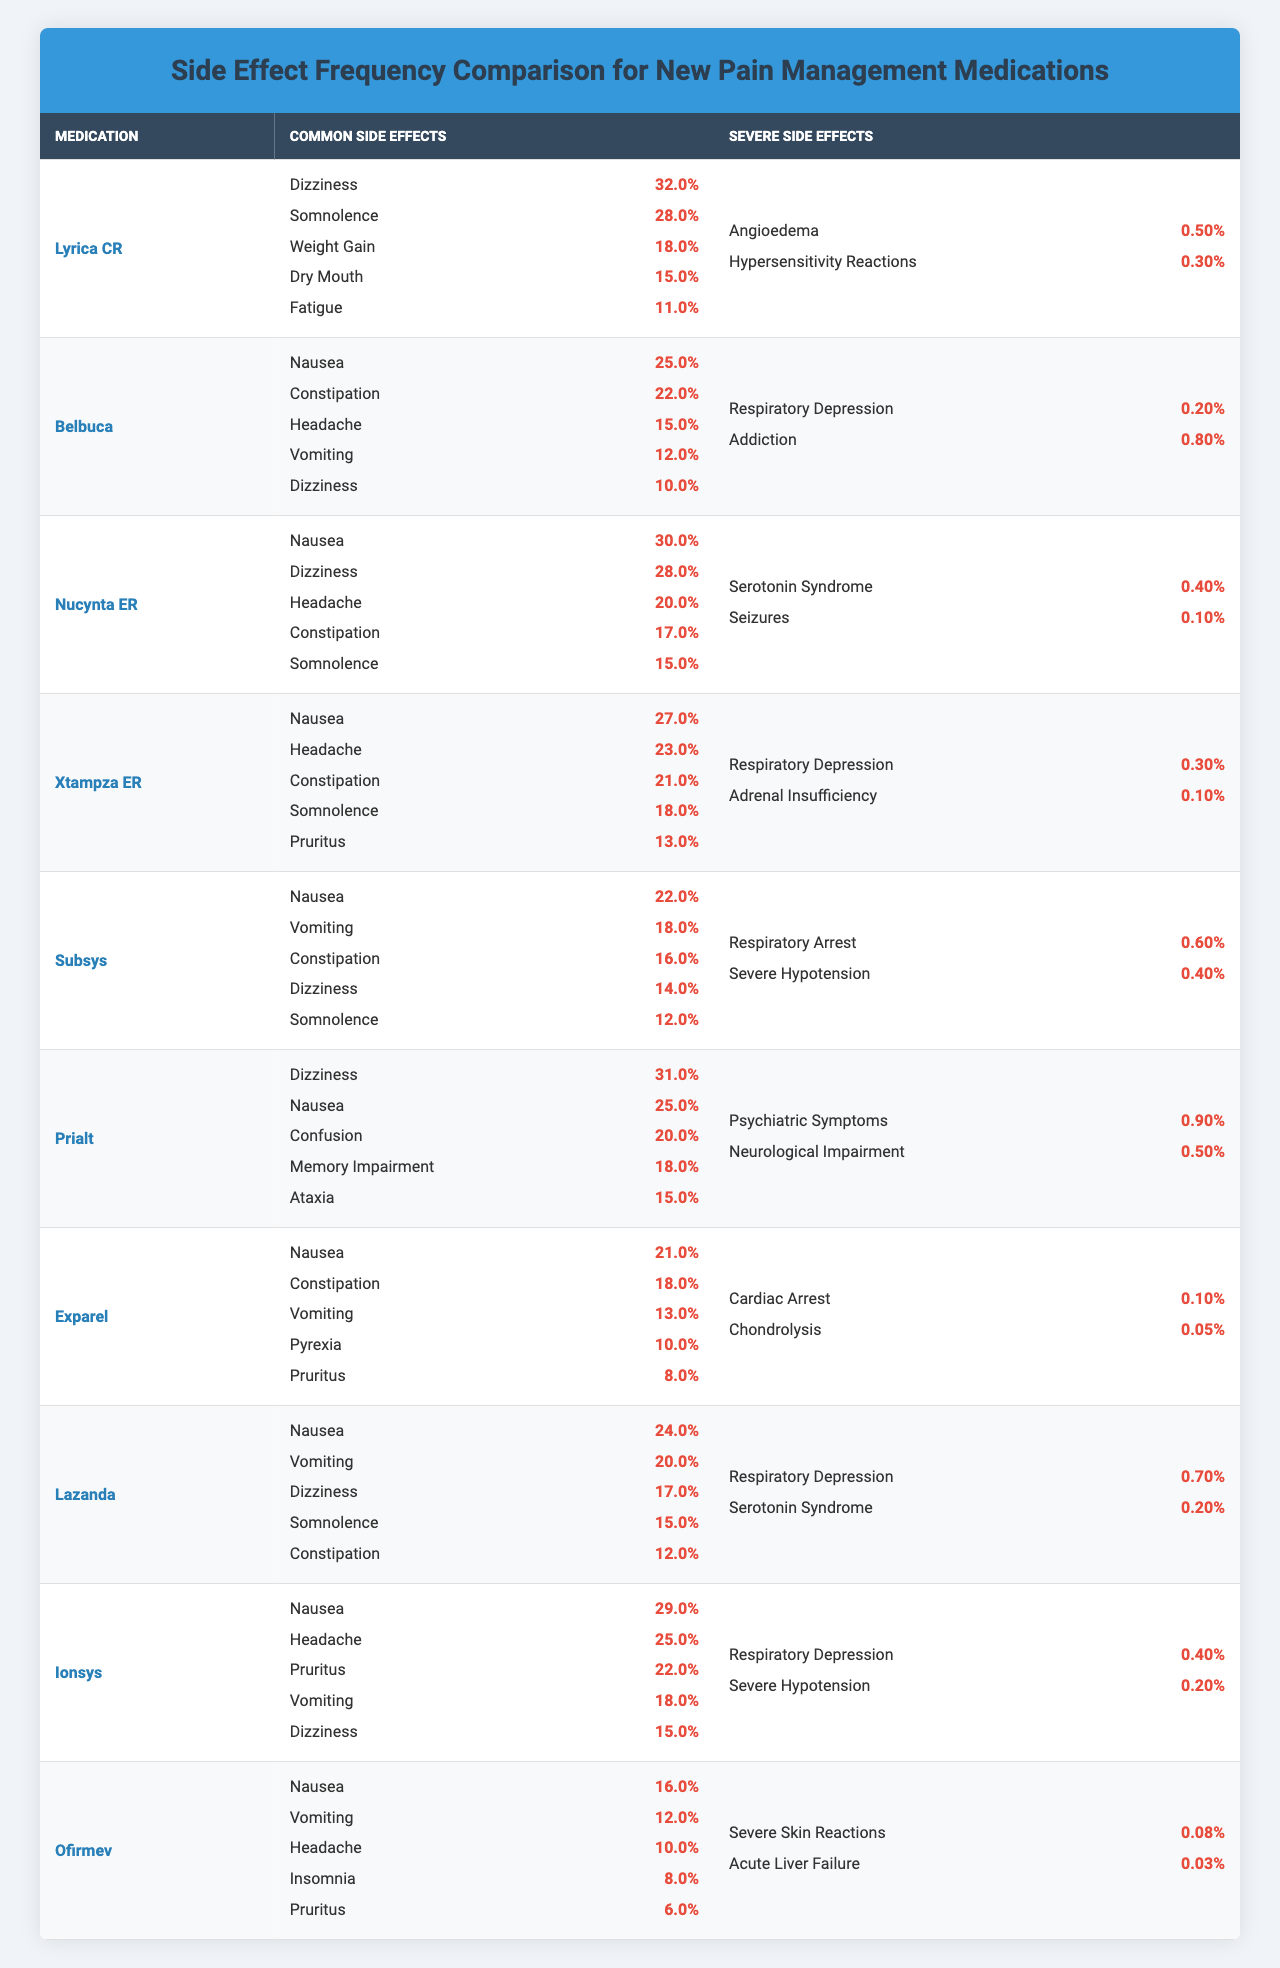What medication has the highest reported frequency of dizziness? Lyrica CR reports a dizziness frequency of 32%, which is the highest among all listed medications. Checking the frequency values in the "Common Side Effects" column confirms this.
Answer: Lyrica CR What is the total frequency of common side effects for Nucynta ER? To find the total frequency of common side effects for Nucynta ER, add the frequency values: 30% (nausea) + 28% (dizziness) + 20% (headache) + 17% (constipation) + 15% (somnolence) = 110%.
Answer: 110% True or False: Subsys has a higher severe side effect frequency for respiratory arrest than Lyrica CR has for angioedema. Checking the percentages, Subsys has a respiratory arrest frequency of 0.6%, while Lyrica CR's angioedema frequency is only 0.5%. Since 0.6% is greater than 0.5%, the statement is True.
Answer: True Which common side effect is the most frequently reported across all medications? To determine this, we review the common side effects for all medications and find that nausea appears with the highest frequency of 30% in Nucynta ER. The next highest frequencies for nausea are found in several others but none exceed 30%.
Answer: Nausea How does the frequency of severe side effects for Belbuca compare to that of Xtampza ER? First, observe the severe side effect frequencies: Belbuca's respiratory depression frequency is 0.2% and addiction frequency is 0.8%, totaling 1.0%. Xtampza ER has respiratory depression at 0.3% and adrenal insufficiency at 0.1%, totaling 0.4%. Therefore, Belbuca has more severe side effects than Xtampza ER.
Answer: Belbuca has higher severe side effects What is the average frequency of somnolence as a side effect among all medications? Somnolence appears in Lyrica CR (28%), Nucynta ER (15%), Xtampza ER (18%), Subsys (12%), Lazanda (15%), resulting in a total of 28% + 15% + 18% + 12% + 15% = 88%. There are 5 instances of somnolence, so the average frequency is 88% / 5 = 17.6%.
Answer: 17.6% Which medication has the lowest reported frequency for any severe side effect? Looking at the severe side effects, Exparel has both cardiac arrest (0.1%) and chondrolysis (0.05%), which are lower than any other medication's severe side effects frequencies.
Answer: Exparel Is the frequency of confusion as a side effect higher in Prialt than in any other medication? Prialt shows a confusion side effect frequency of 20%. The maximum confusion frequency in the table is 20%, matched by no other medication, indicating that Prialt is the only one reporting confusion at this frequency.
Answer: Yes, Prialt is the highest 